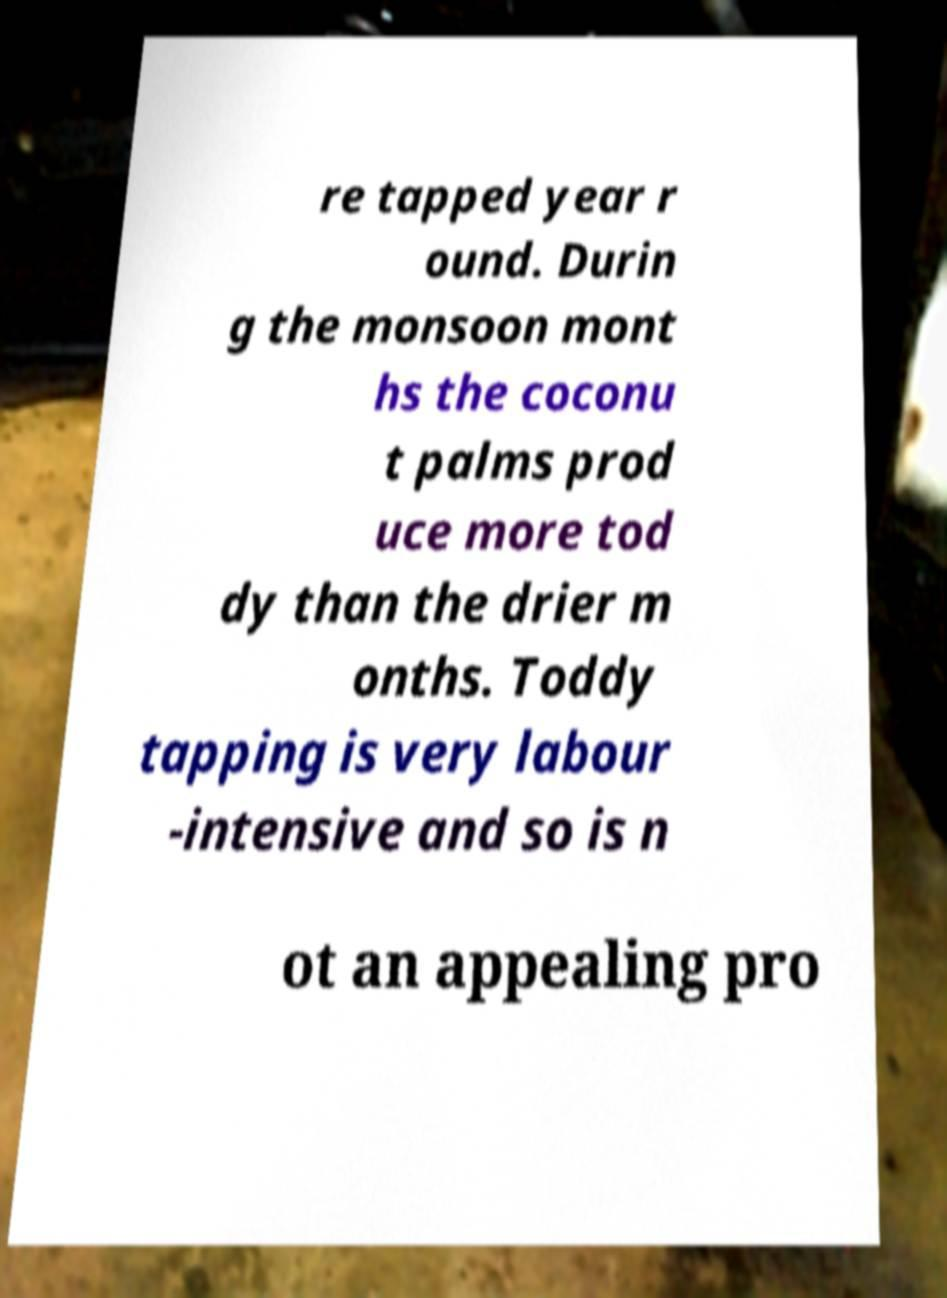Could you assist in decoding the text presented in this image and type it out clearly? re tapped year r ound. Durin g the monsoon mont hs the coconu t palms prod uce more tod dy than the drier m onths. Toddy tapping is very labour -intensive and so is n ot an appealing pro 